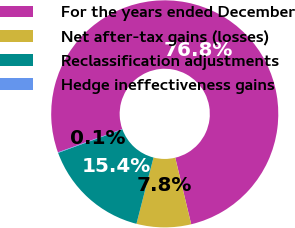<chart> <loc_0><loc_0><loc_500><loc_500><pie_chart><fcel>For the years ended December<fcel>Net after-tax gains (losses)<fcel>Reclassification adjustments<fcel>Hedge ineffectiveness gains<nl><fcel>76.76%<fcel>7.75%<fcel>15.41%<fcel>0.08%<nl></chart> 